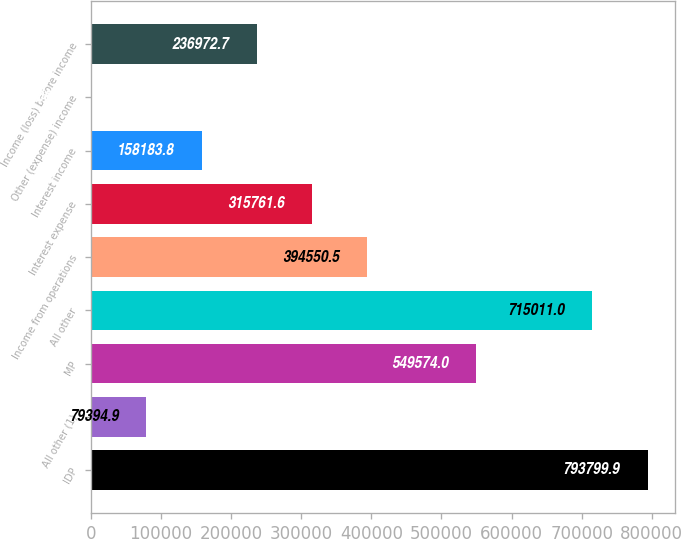Convert chart to OTSL. <chart><loc_0><loc_0><loc_500><loc_500><bar_chart><fcel>IDP<fcel>All other (1)<fcel>MP<fcel>All other<fcel>Income from operations<fcel>Interest expense<fcel>Interest income<fcel>Other (expense) income<fcel>Income (loss) before income<nl><fcel>793800<fcel>79394.9<fcel>549574<fcel>715011<fcel>394550<fcel>315762<fcel>158184<fcel>606<fcel>236973<nl></chart> 